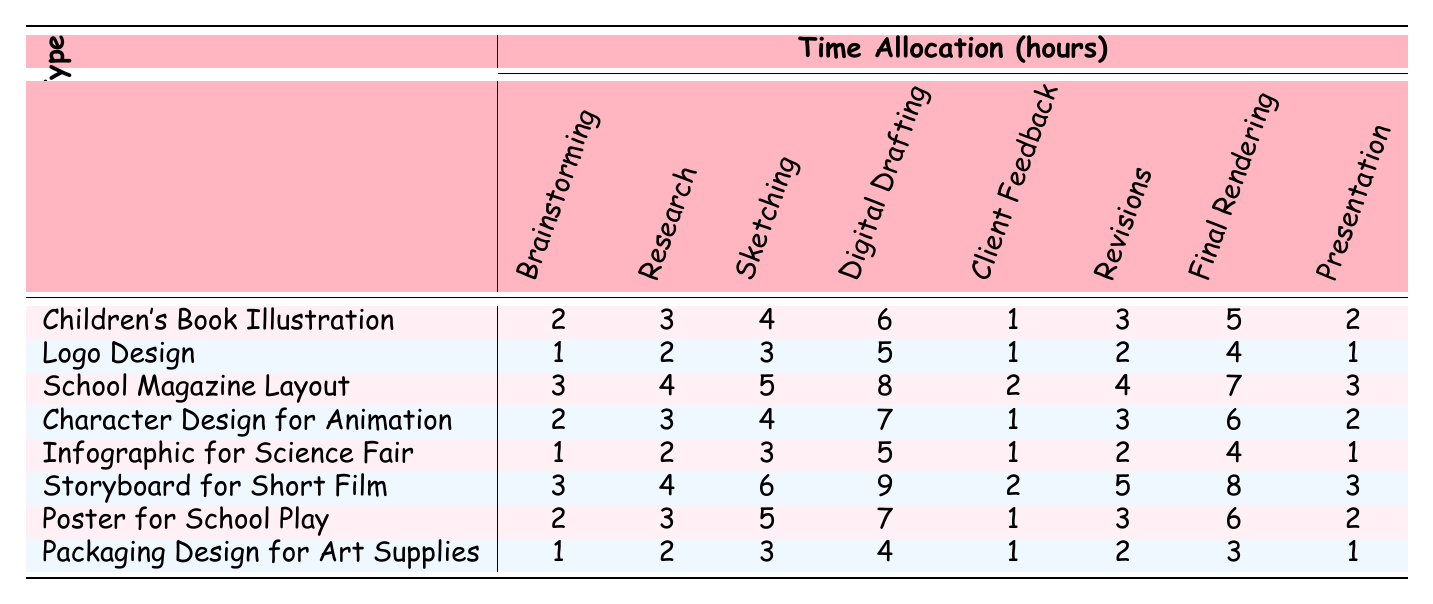What is the total time allocated for "Research" in the "Children's Book Illustration" project? From the table, the time allocated for "Research" in the "Children's Book Illustration" project is 3 hours.
Answer: 3 What is the time allocation for "Final Rendering" in the "Storyboard for Short Film"? The table shows that the time allocated for "Final Rendering" in the "Storyboard for Short Film" project is 8 hours.
Answer: 8 Which project type has the least time allocated for "Client Feedback"? By examining the table, the "Children's Book Illustration" project has the least time allocated for "Client Feedback," which is 1 hour.
Answer: Children's Book Illustration What is the sum of the time allocations for the "Sketching" stage across all project types? The time allocations for "Sketching" are 4, 3, 5, 4, 3, 6, 5, and 3 hours. Adding these gives a total of (4 + 3 + 5 + 4 + 3 + 6 + 5 + 3) = 33 hours.
Answer: 33 Which project type has the highest total time allocation and what is that total? By summing up the time allocations for each project type, "Storyboard for Short Film" has the highest total of (3 + 4 + 6 + 9 + 2 + 5 + 8 + 3) = 40 hours.
Answer: Storyboard for Short Film, 40 Is the time allocated for "Digital Drafting" in "School Magazine Layout" greater than in "Packaging Design for Art Supplies"? Looking at the table, "Digital Drafting" has 8 hours for "School Magazine Layout" and 4 hours for "Packaging Design for Art Supplies." 8 > 4 is true, so the statement is correct.
Answer: Yes What is the average time allocated for the "Brainstorming" stage across all project types? The time allocations for "Brainstorming" are (2 + 1 + 3 + 2 + 1 + 3 + 2 + 1) = 15 hours. Since there are 8 project types, the average is 15/8 = 1.875 hours.
Answer: 1.875 How much more time is spent on "Revisions" in "Storyboard for Short Film" compared to "Logo Design"? For "Storyboard for Short Film," the time for "Revisions" is 5 hours, and for "Logo Design," it is 2 hours. The difference is 5 - 2 = 3 hours, meaning 3 more hours are spent on "Storyboard for Short Film."
Answer: 3 What is the median time allocated for the "Presentation" stage across all projects? The time allocations for "Presentation" are 2, 1, 3, 2, 1, 3, 2, and 1 hours. Sorting these gives {1, 1, 1, 1, 2, 2, 2, 3}. The median (middle) for 8 numbers is (1 + 2) / 2 = 1.5 hours.
Answer: 1.5 Which project type has a higher time allocation for "Sketching," "Digital Drafting," or "Final Rendering"? Comparing the highest values: "Sketching" highest is 5, "Digital Drafting" highest is 9, and "Final Rendering" highest is 8. Therefore, "Digital Drafting" has the highest allocation.
Answer: Digital Drafting 